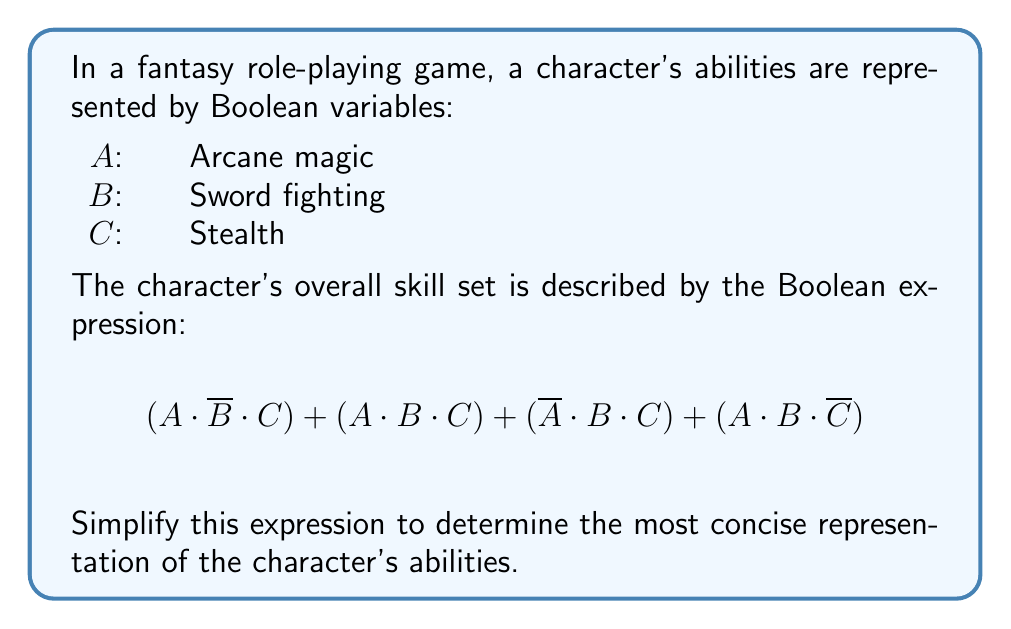Could you help me with this problem? Let's simplify this Boolean expression step-by-step:

1) First, we can factor out the common term $C$ from the first three terms:
   $C(A \cdot \overline{B} + A \cdot B + \overline{A} \cdot B) + (A \cdot B \cdot \overline{C})$

2) Inside the parentheses, we can simplify further:
   $A \cdot \overline{B} + A \cdot B = A(\overline{B} + B) = A$
   So, we have: $C(A + \overline{A} \cdot B) + (A \cdot B \cdot \overline{C})$

3) Now, $A + \overline{A} \cdot B$ can be simplified:
   $A + \overline{A} \cdot B = A + B$ (this is the absorption law)

4) Our expression is now:
   $C(A + B) + (A \cdot B \cdot \overline{C})$

5) Expanding this:
   $C \cdot A + C \cdot B + A \cdot B \cdot \overline{C}$

6) We can rearrange the terms:
   $A \cdot C + B \cdot C + A \cdot B \cdot \overline{C}$

7) The first two terms can be combined:
   $(A + B) \cdot C + A \cdot B \cdot \overline{C}$

This is the most simplified form of the expression.
Answer: $(A + B) \cdot C + A \cdot B \cdot \overline{C}$ 